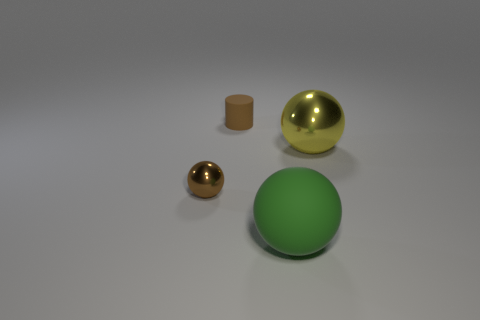What is the shape of the tiny thing that is behind the tiny brown metallic object?
Ensure brevity in your answer.  Cylinder. There is a small thing that is in front of the brown thing that is behind the brown metal thing; are there any large objects in front of it?
Make the answer very short. Yes. What material is the big yellow thing that is the same shape as the small shiny object?
Make the answer very short. Metal. How many cubes are either large metallic objects or big green things?
Your response must be concise. 0. There is a shiny sphere on the left side of the tiny brown rubber cylinder; is it the same size as the shiny object on the right side of the small rubber cylinder?
Make the answer very short. No. What is the big sphere that is in front of the large yellow shiny ball that is right of the small matte thing made of?
Provide a succinct answer. Rubber. Are there fewer small brown metal objects that are in front of the small ball than tiny brown matte cylinders?
Your answer should be compact. Yes. What is the shape of the green thing that is made of the same material as the tiny brown cylinder?
Provide a short and direct response. Sphere. What number of other objects are there of the same shape as the brown shiny thing?
Your response must be concise. 2. What number of brown objects are either large balls or matte things?
Make the answer very short. 1. 